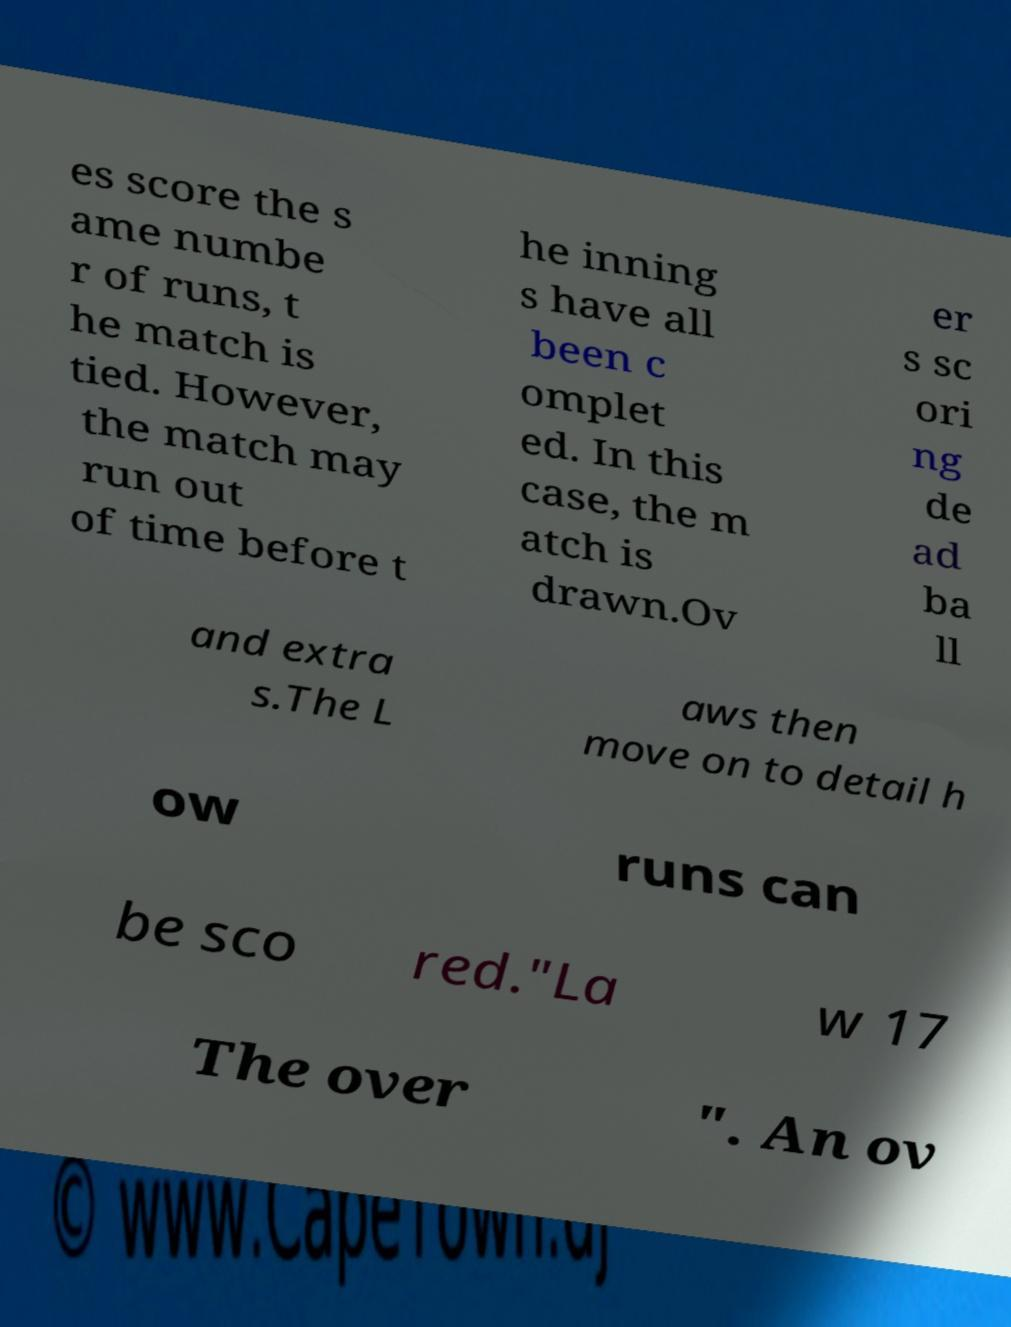What messages or text are displayed in this image? I need them in a readable, typed format. es score the s ame numbe r of runs, t he match is tied. However, the match may run out of time before t he inning s have all been c omplet ed. In this case, the m atch is drawn.Ov er s sc ori ng de ad ba ll and extra s.The L aws then move on to detail h ow runs can be sco red."La w 17 The over ". An ov 